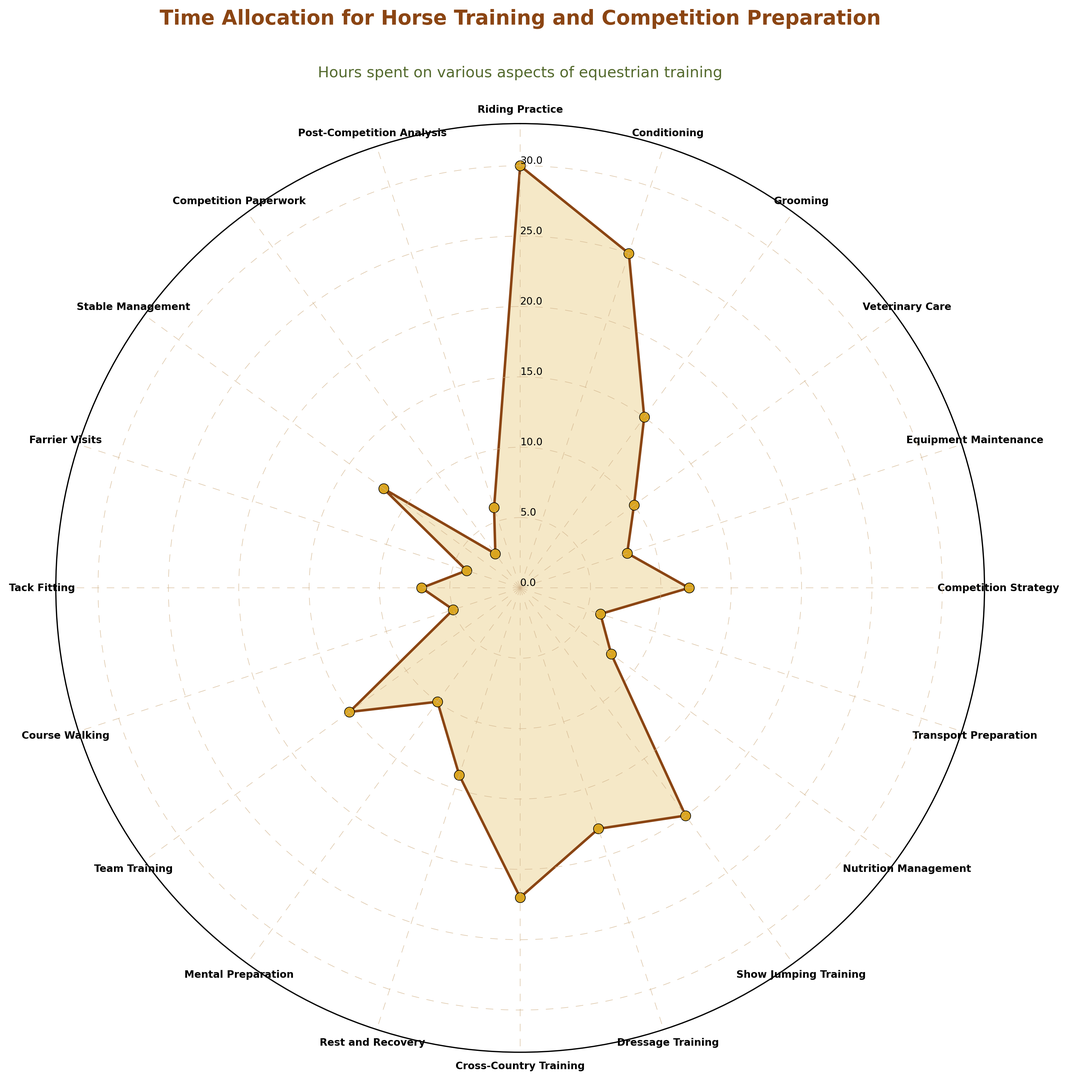What's the total time spent on `Conditioning` and `Show Jumping Training`? To find the total time spent on both activities, we simply add their respective hours: 25 hours for Conditioning + 20 hours for Show Jumping Training = 45 hours.
Answer: 45 hours Which aspect has the highest allocation of hours? By observing the lengths of the segments, we can see that `Riding Practice` has the longest segment, indicating the highest allocation of hours at 30 hours.
Answer: Riding Practice Compare the time spent on `Dressage Training` and `Cross-Country Training`. Which one has more hours? To determine which training has more hours, we compare the segment lengths (or hour values): Dressage Training has 18 hours, while Cross-Country Training has 22 hours. Therefore, Cross-Country Training has more hours.
Answer: Cross-Country Training What is the difference in hours between `Nutrition Management` and `Post-Competition Analysis`? To find the difference, we subtract the hours spent on Post-Competition Analysis from the hours spent on Nutrition Management: 8 hours - 6 hours = 2 hours.
Answer: 2 hours Identify the visual aspect with the fewest hours allocated. By observing the shortest segment, we identify `Competition Paperwork` as having the fewest hours allocated, which is 3 hours.
Answer: Competition Paperwork How many hours are spent on `Veterinary Care` versus `Mental Preparation`? By comparing the segments or values, Veterinary Care has 10 hours, and Mental Preparation also has 10 hours, which is equal.
Answer: Both are 10 hours What is the sum of hours spent on `Team Training`, `Stable Management`, and `Farrier Visits`? To find the total time: 15 hours (Team Training) + 12 hours (Stable Management) + 4 hours (Farrier Visits) = 31 hours.
Answer: 31 hours Calculate the average hours spent on `Competition Strategy`, `Transport Preparation`, and `Course Walking`. First, sum the hours: 12 hours (Competition Strategy) + 6 hours (Transport Preparation) + 5 hours (Course Walking) = 23 hours. Next, divide by 3: 23 hours / 3 = 7.67 hours.
Answer: 7.67 hours Is the time spent on `Grooming` greater than, less than, or equal to the time spent on `Rest and Recovery`? By comparing the values, Grooming has 15 hours and Rest and Recovery has 14 hours. Therefore, Grooming has more hours.
Answer: Greater Which three aspects have the highest allocated time, and what are their combined hours? The top three aspects with the highest time are: `Riding Practice` (30 hours), `Cross-Country Training` (22 hours), and `Show Jumping Training` (20 hours). Combined, they total: 30 hours + 22 hours + 20 hours = 72 hours.
Answer: Riding Practice, Cross-Country Training, Show Jumping Training; 72 hours 